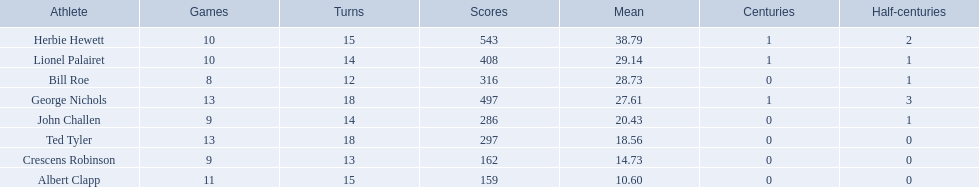Who are the players in somerset county cricket club in 1890? Herbie Hewett, Lionel Palairet, Bill Roe, George Nichols, John Challen, Ted Tyler, Crescens Robinson, Albert Clapp. Who is the only player to play less than 13 innings? Bill Roe. Which players played in 10 or fewer matches? Herbie Hewett, Lionel Palairet, Bill Roe, John Challen, Crescens Robinson. Of these, which played in only 12 innings? Bill Roe. 